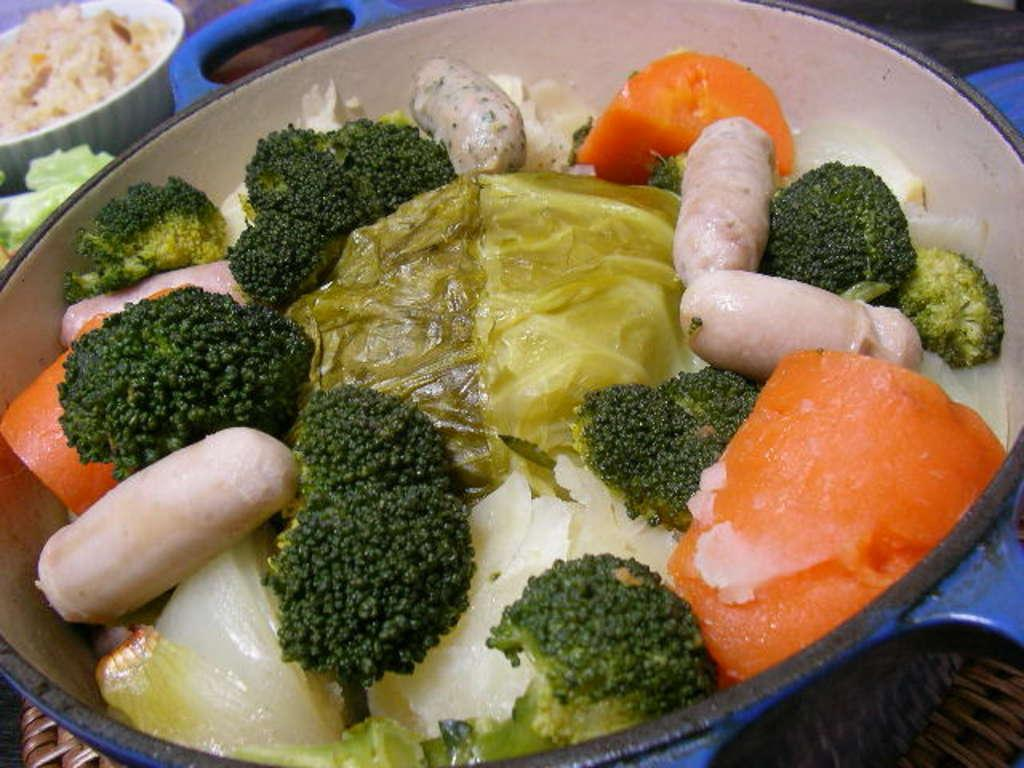What is the main piece of furniture in the image? There is a table in the image. What is placed on the table? There are bowls on the table. What is inside the bowls? The bowls contain different types of dishes. What type of cracker is being used to make a salad in the image? There is no cracker or salad present in the image. How many lettuce leaves are visible in the image? There is no lettuce present in the image. 